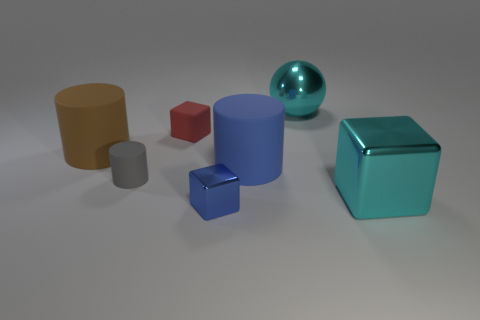Add 1 blue metal cylinders. How many objects exist? 8 Subtract all cylinders. How many objects are left? 4 Subtract 0 green blocks. How many objects are left? 7 Subtract all tiny blue metal blocks. Subtract all small brown shiny things. How many objects are left? 6 Add 4 small metallic blocks. How many small metallic blocks are left? 5 Add 1 cylinders. How many cylinders exist? 4 